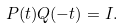<formula> <loc_0><loc_0><loc_500><loc_500>P ( t ) Q ( - t ) = I .</formula> 